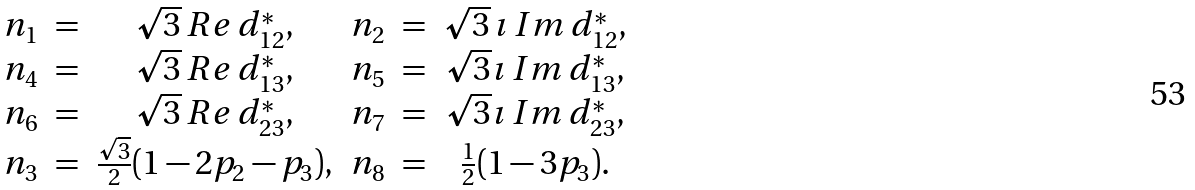Convert formula to latex. <formula><loc_0><loc_0><loc_500><loc_500>\begin{array} { c c c c c c } n _ { 1 } & = & \sqrt { 3 } \, R e \, d _ { 1 2 } ^ { * } , & n _ { 2 } & = & \sqrt { 3 } \, \imath \, I m \, d _ { 1 2 } ^ { * } , \\ n _ { 4 } & = & \sqrt { 3 } \, R e \, d _ { 1 3 } ^ { * } , & n _ { 5 } & = & \sqrt { 3 } \imath \, I m \, d _ { 1 3 } ^ { * } , \\ n _ { 6 } & = & \sqrt { 3 } \, R e \, d _ { 2 3 } ^ { * } , & n _ { 7 } & = & \sqrt { 3 } \imath \, I m \, d _ { 2 3 } ^ { * } , \\ n _ { 3 } & = & \frac { \sqrt { 3 } } { 2 } ( 1 - 2 p _ { 2 } - p _ { 3 } ) , & n _ { 8 } & = & \frac { 1 } { 2 } ( 1 - 3 p _ { 3 } ) . \end{array}</formula> 